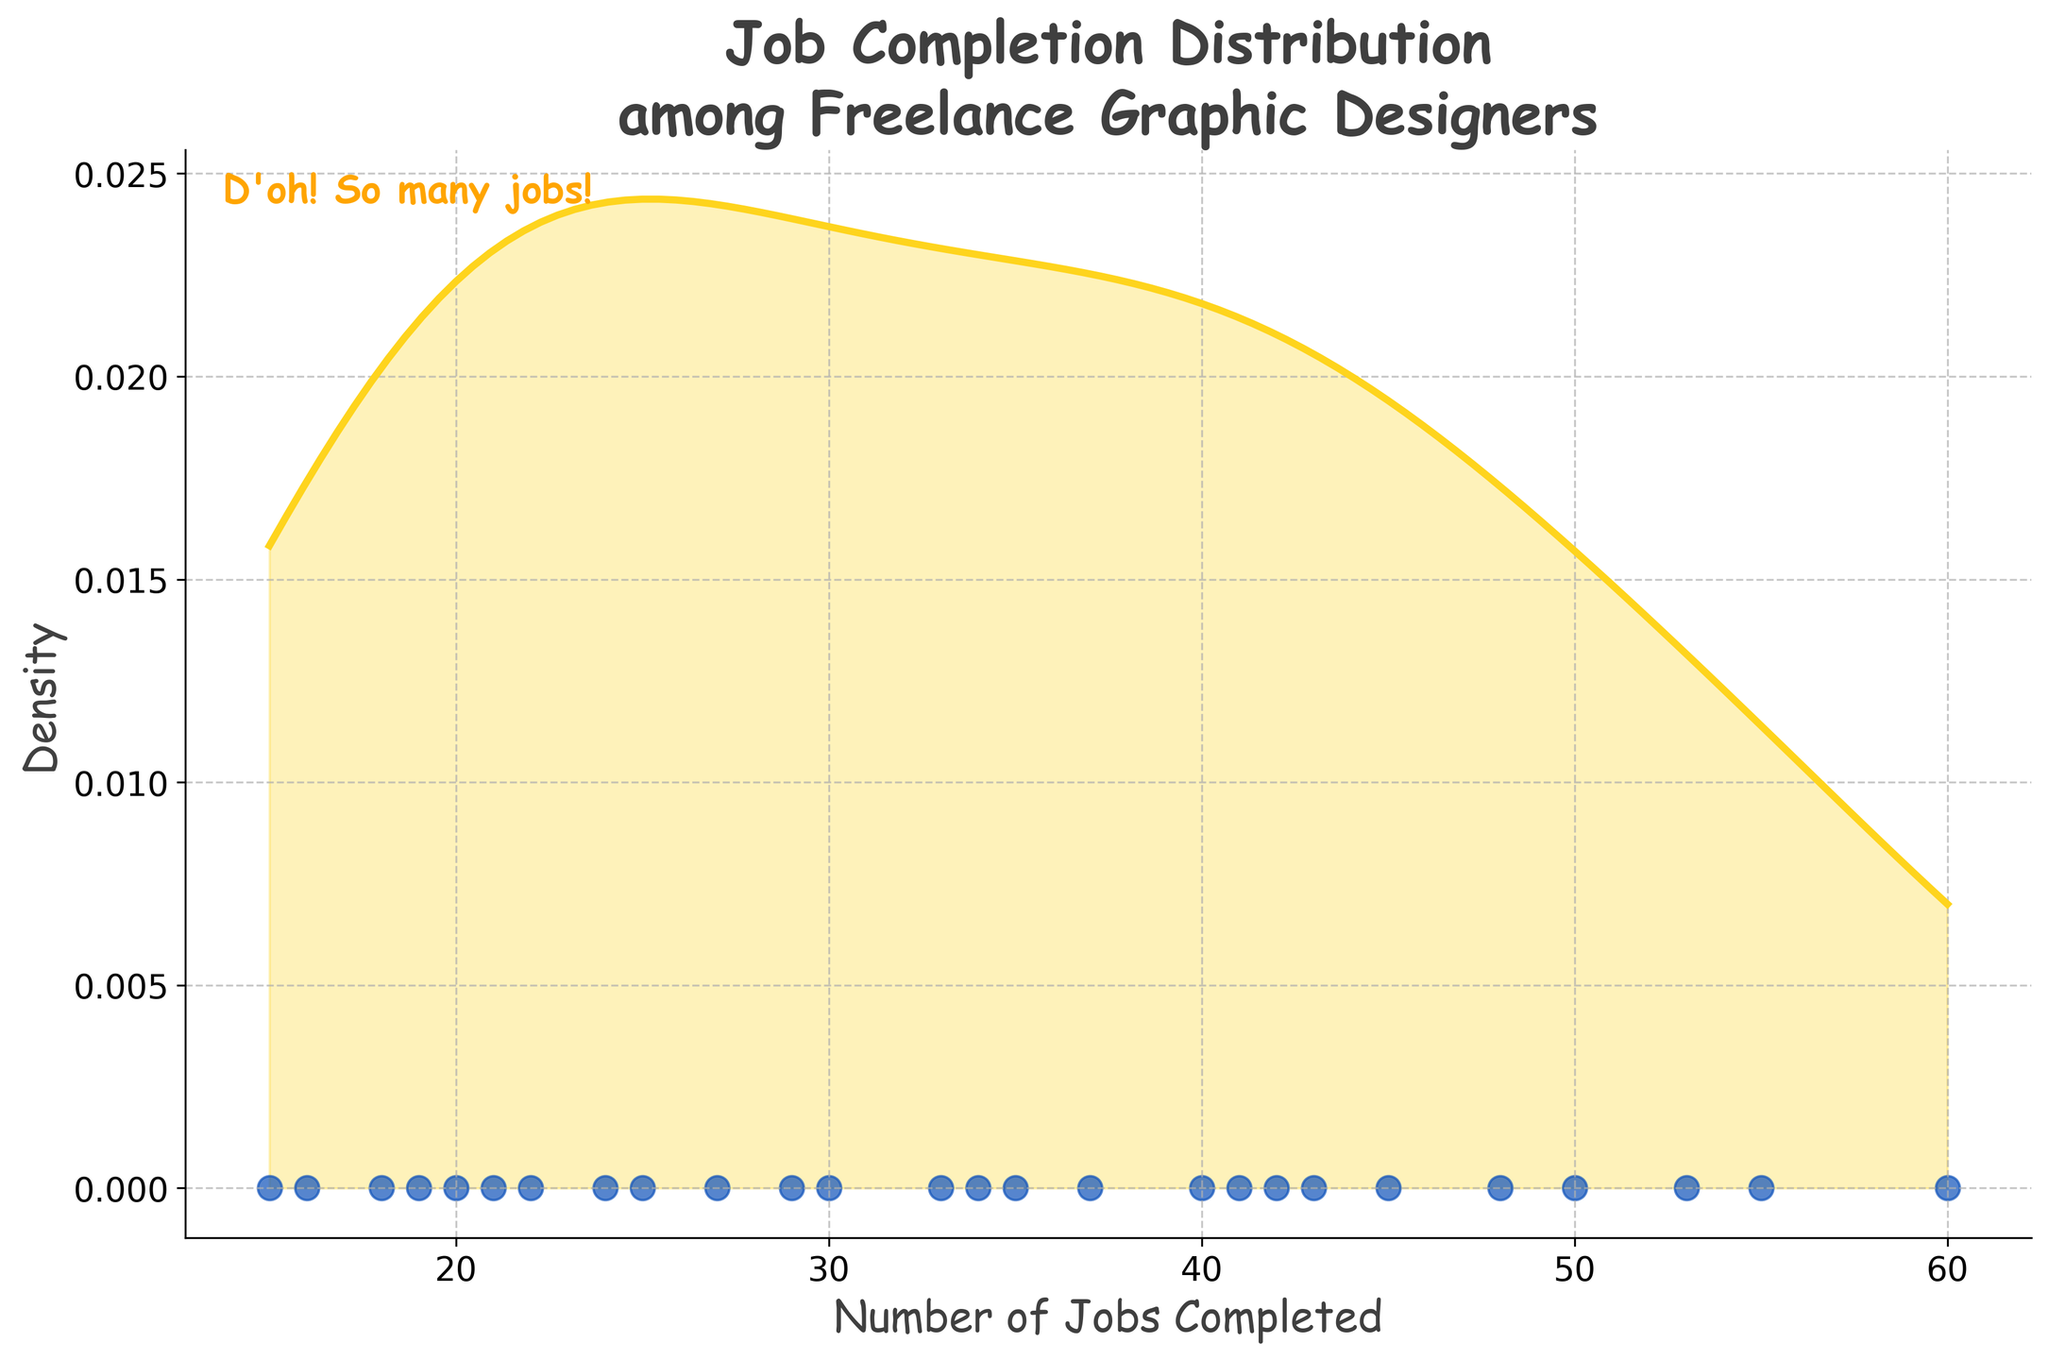What is the title of the plot? The title is often positioned at the top of the figure and is usually the largest text that provides a summary of what the plot represents.
Answer: Job Completion Distribution among Freelance Graphic Designers How many data points are visualized in the scatter plot? On a density plot where each data point is marked with a specific symbol or dot, you just count the number of those marks. In this case, there are 26 data points for each freelancer.
Answer: 26 What color is used to represent the kernel density estimation line? Observing the plot, the kernel density estimation line is plotted using a color that's distinctly different from the scatter plot points and background. In this plot, it is a shade of yellow.
Answer: Yellow What does the x-axis represent? The x-axis label indicates the variable it represents in the plot. Here, it is labeled as "Number of Jobs Completed."
Answer: Number of Jobs Completed Which freelancer completed the highest number of jobs? You need to look at the highest point in the scatter plot on the x-axis to determine this freelancer's data point.
Answer: Freelancer_Ina What is the range of the number of jobs completed among all freelancers? To find the range, you identify the minimum and maximum job counts from the plot's x-axis and subtract the minimum from the maximum. The data ranges from 15 to 60 jobs completed.
Answer: 45 (60 - 15) Which two freelancers completed the closest number of jobs? By examining the scatter plot and looking for two points that are very close together on the x-axis, you can determine which freelancers have nearly the same number of completed jobs. In this plot, Freelancers Diane and Hank completed 30 and 29 jobs, respectively.
Answer: Diane and Hank What density value corresponds to the highest peak on the density plot? The highest peak in the density plot indicates the mode or the most frequent number of jobs completed. You can read the corresponding density value on the y-axis.
Answer: Around 0.025 Between which job completion numbers does the highest density occur? The highest density region appears as the peak of the plot, so you look at the x-axis range under the peak. In this plot, it is between about 25 to 45 jobs completed.
Answer: 25 to 45 jobs completed Is there a significant gap between any two data points in the scatter plot? Observing the scatter plot, you look for wide spaces between points on the x-axis. Here, there is a noticeable gap between 29 and 33 jobs completed.
Answer: Yes, between 29 and 33 jobs 